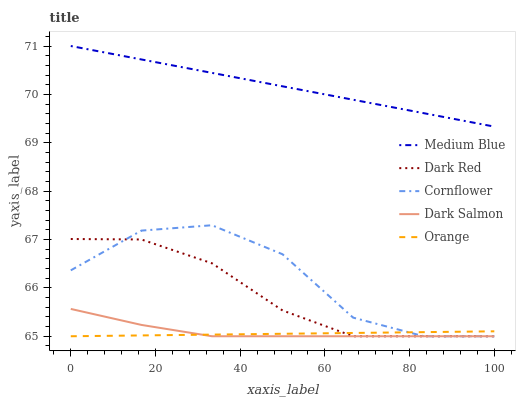Does Orange have the minimum area under the curve?
Answer yes or no. Yes. Does Medium Blue have the maximum area under the curve?
Answer yes or no. Yes. Does Dark Red have the minimum area under the curve?
Answer yes or no. No. Does Dark Red have the maximum area under the curve?
Answer yes or no. No. Is Orange the smoothest?
Answer yes or no. Yes. Is Cornflower the roughest?
Answer yes or no. Yes. Is Dark Red the smoothest?
Answer yes or no. No. Is Dark Red the roughest?
Answer yes or no. No. Does Orange have the lowest value?
Answer yes or no. Yes. Does Medium Blue have the lowest value?
Answer yes or no. No. Does Medium Blue have the highest value?
Answer yes or no. Yes. Does Dark Red have the highest value?
Answer yes or no. No. Is Dark Red less than Medium Blue?
Answer yes or no. Yes. Is Medium Blue greater than Orange?
Answer yes or no. Yes. Does Orange intersect Dark Salmon?
Answer yes or no. Yes. Is Orange less than Dark Salmon?
Answer yes or no. No. Is Orange greater than Dark Salmon?
Answer yes or no. No. Does Dark Red intersect Medium Blue?
Answer yes or no. No. 